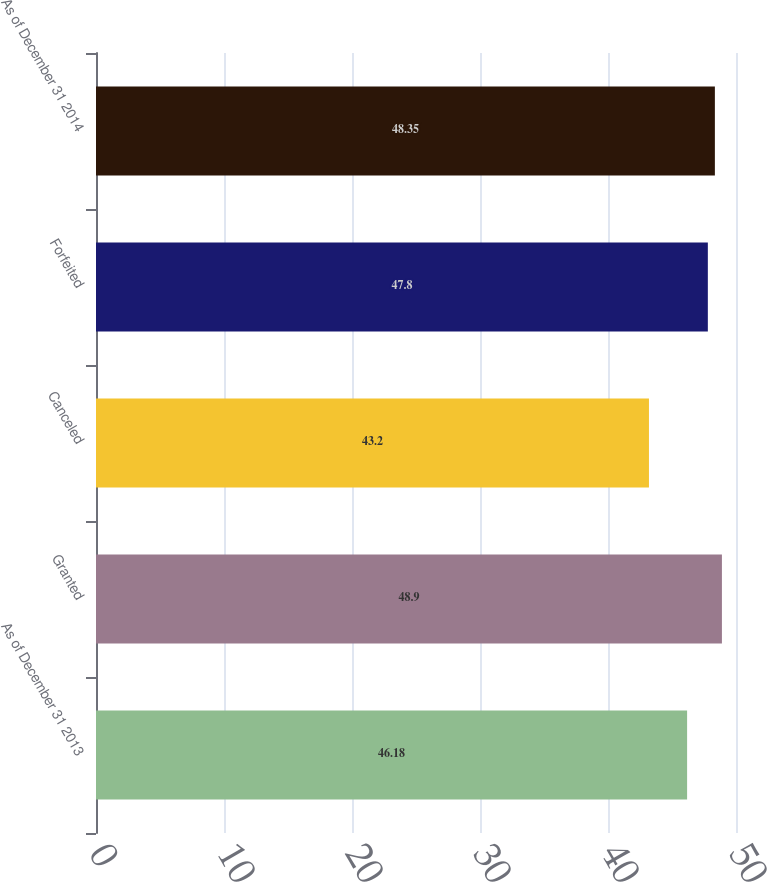<chart> <loc_0><loc_0><loc_500><loc_500><bar_chart><fcel>As of December 31 2013<fcel>Granted<fcel>Canceled<fcel>Forfeited<fcel>As of December 31 2014<nl><fcel>46.18<fcel>48.9<fcel>43.2<fcel>47.8<fcel>48.35<nl></chart> 